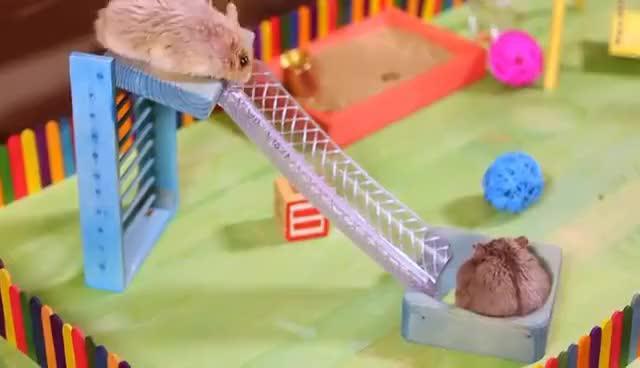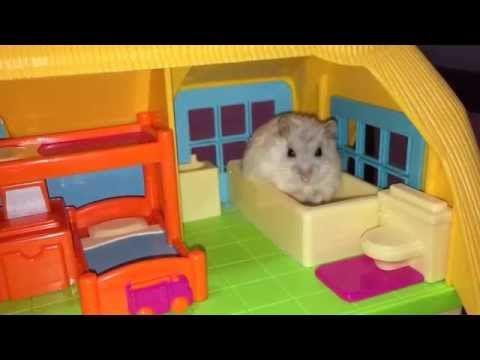The first image is the image on the left, the second image is the image on the right. Assess this claim about the two images: "Two hamsters are on swings.". Correct or not? Answer yes or no. No. The first image is the image on the left, the second image is the image on the right. For the images shown, is this caption "Th e image on the left contains two hamsters." true? Answer yes or no. Yes. 